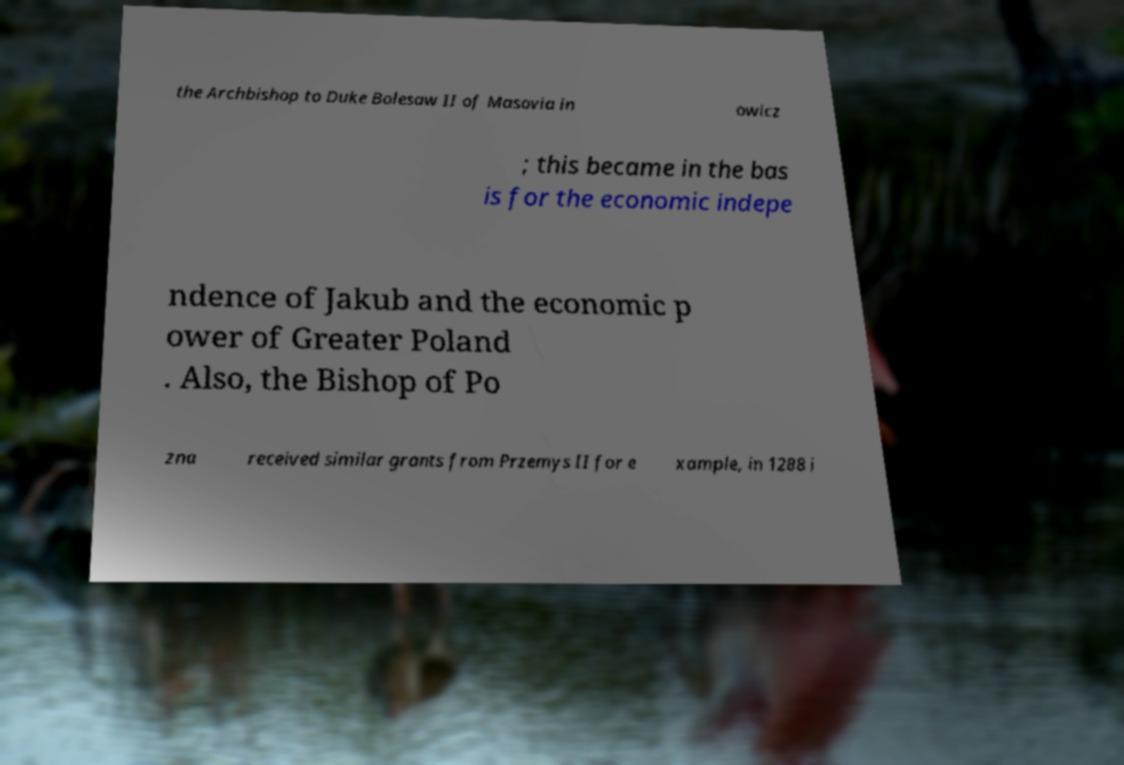Please identify and transcribe the text found in this image. the Archbishop to Duke Bolesaw II of Masovia in owicz ; this became in the bas is for the economic indepe ndence of Jakub and the economic p ower of Greater Poland . Also, the Bishop of Po zna received similar grants from Przemys II for e xample, in 1288 i 